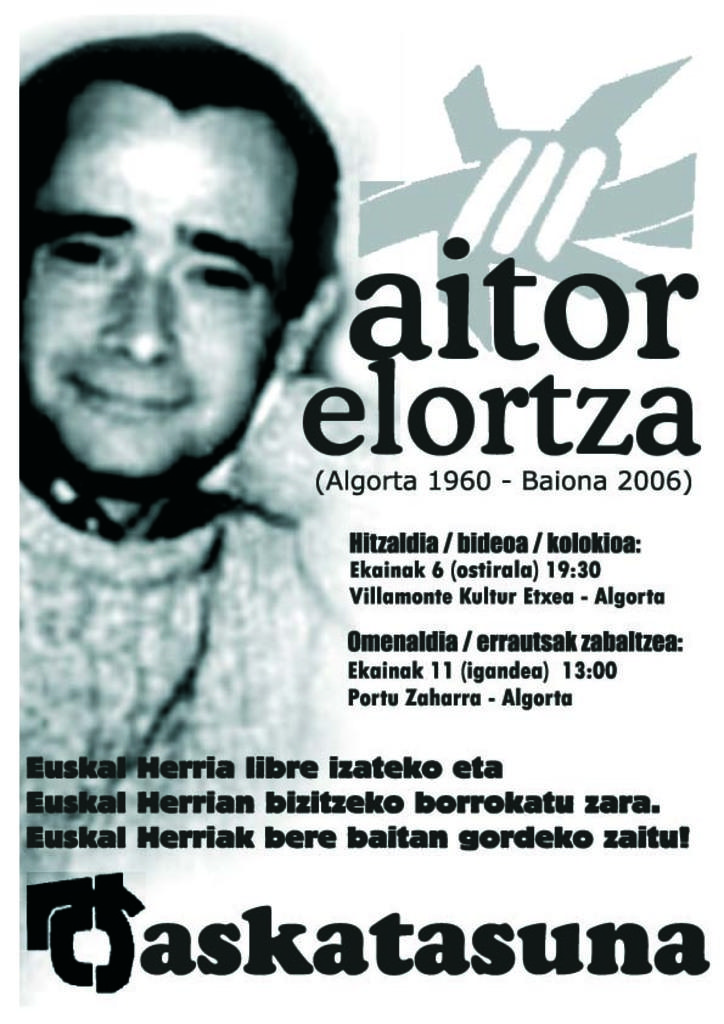Who is present in the image? There is a man in the image. What else can be seen in the image besides the man? There is writing in the image. What type of oatmeal is the man eating in the image? There is no oatmeal present in the image, and the man's actions are not described. 